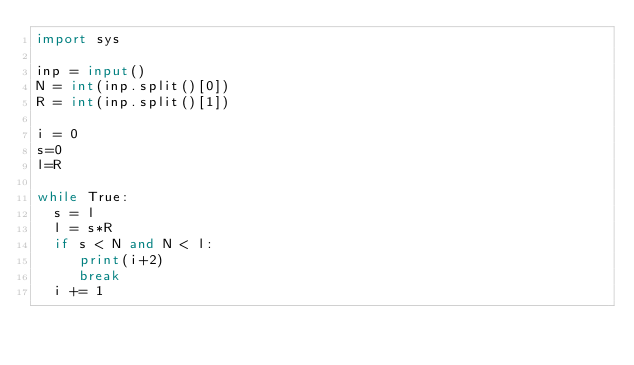<code> <loc_0><loc_0><loc_500><loc_500><_Python_>import sys

inp = input()
N = int(inp.split()[0])
R = int(inp.split()[1])

i = 0
s=0
l=R

while True:
  s = l
  l = s*R
  if s < N and N < l:
     print(i+2)
     break
  i += 1</code> 